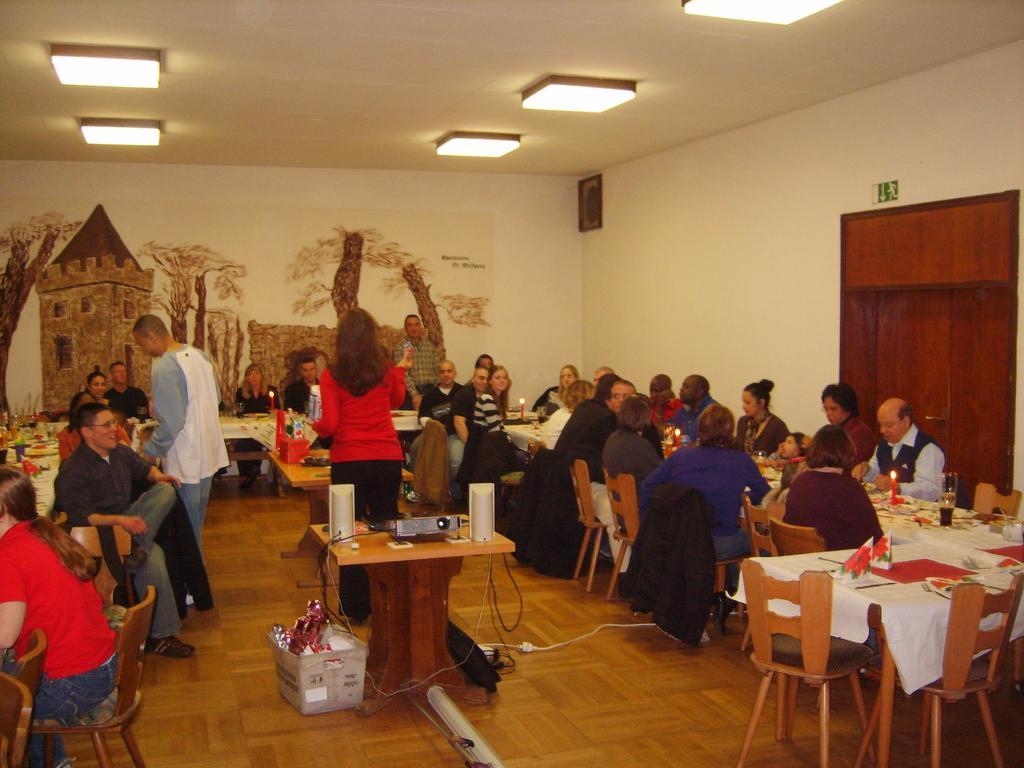Describe this image in one or two sentences. In this image I can see number of people where two are standing and rest all are sitting on chairs. I can also see few empty chairs, number of tables, white colour table cloths and on these tables I can see few glasses and few other stuffs. Here I can see a projector machine, few speakers and in the background I can see painting on this wall and here I can see few lights. 